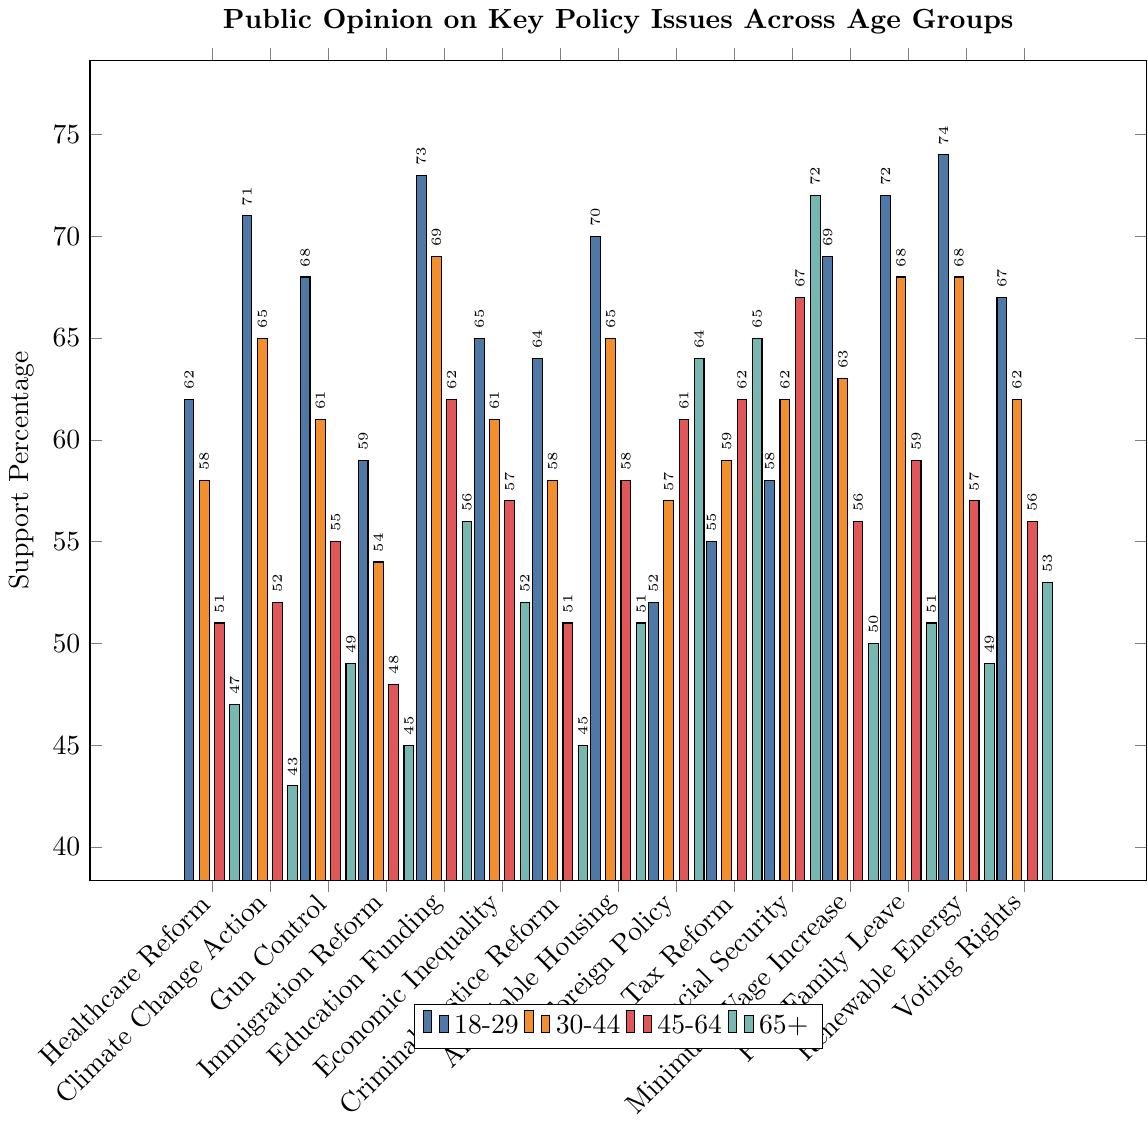Which issue has the highest support percentage from the 18-29 age group? The highest support percentage can be found by comparing the values for the 18-29 age group across all issues. Renewable Energy has the highest support with 74%.
Answer: Renewable Energy Which age group shows the least support for Climate Change Action? To determine the age group with the least support for Climate Change Action, compare the percentages for all age groups for this issue. The 65+ age group shows the least support at 43%.
Answer: 65+ Calculate the average support percentage for Education Funding across all age groups. Average is the sum of percentages divided by the number of groups. The percentages for Education Funding across age groups are 73, 69, 62, and 56. (73 + 69 + 62 + 56) / 4 = 260 / 4 = 65%
Answer: 65% By how much does support for Affordable Housing among the 18-29 age group differ from the 65+ age group? The difference is found by subtracting the 65+ percentage from the 18-29 percentage for Affordable Housing. 70 - 51 = 19%
Answer: 19% Which issue has the most uniform support distribution across all age groups (i.e., the smallest difference between highest and lowest support percentages)? Calculate the range (difference between highest and lowest support percentages) for each issue and compare. For Gun Control: 68-49=19, for Education Funding: 73-56=17, for Foreign Policy: 64-52=12, etc. Foreign Policy has the smallest range of 12%.
Answer: Foreign Policy Which age group shows the highest support for Social Security and what is the percentage? Compare the support percentages for Social Security across the age groups. The 65+ age group shows the highest support at 72%.
Answer: 65+ at 72% Identify the issue for which the 30-44 age group has the lowest support. Examine the support percentages for the 30-44 age group across all issues. Climate Change Action has the lowest support at 65%.
Answer: Climate Change Action Between Renewable Energy and Voting Rights, which issue has a higher average support percentage across all age groups? Compute the average for both issues. Renewable Energy: (74+68+57+49)/4 = 62, Voting Rights: (67+62+56+53)/4 = 59.5. Renewable Energy has a higher average support.
Answer: Renewable Energy How much higher is the support for Healthcare Reform among the 18-29 age group compared to the 45-64 age group? Subtract the 45-64 percentage from the 18-29 percentage for Healthcare Reform. 62 - 51 = 11%
Answer: 11% Which issue shows a decreasing trend in support as age increases? Examine the pattern of support percentages from 18-29 to 65+ for each issue. Issues like Renewable Energy (74, 68, 57, 49) show a consistent decrease as age increases.
Answer: Renewable Energy 